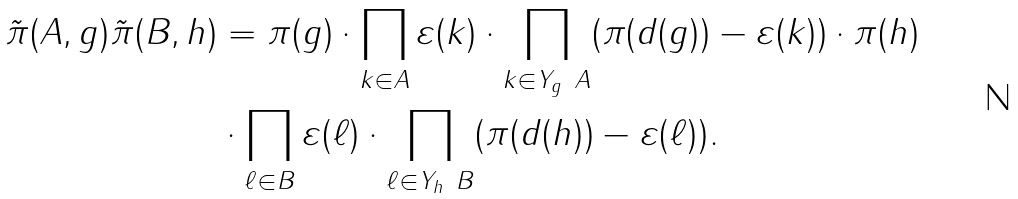<formula> <loc_0><loc_0><loc_500><loc_500>\tilde { \pi } ( A , g ) \tilde { \pi } ( B , h ) & = \pi ( g ) \cdot \prod _ { k \in A } \varepsilon ( k ) \cdot \prod _ { k \in Y _ { g } \ A } ( \pi ( d ( g ) ) - \varepsilon ( k ) ) \cdot \pi ( h ) \\ & \cdot \prod _ { \ell \in B } \varepsilon ( \ell ) \cdot \prod _ { \ell \in Y _ { h } \ B } ( \pi ( d ( h ) ) - \varepsilon ( \ell ) ) .</formula> 